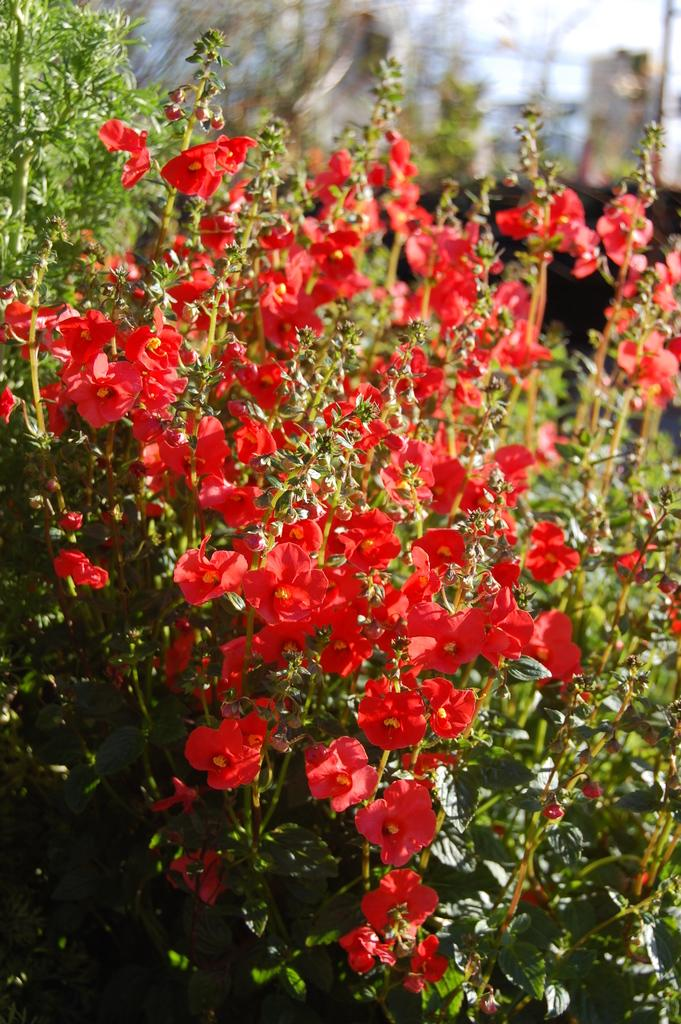What type of flowers can be seen in the front of the image? There are red color flowers in the front of the image. Where is the pole located in the image? The pole is on the top right side of the image. How would you describe the overall clarity of the image? The image is slightly blurry in the background. How many cows are present on the shelf in the image? There are no cows or shelves present in the image. What type of farm can be seen in the background of the image? There is no farm visible in the image; it features red color flowers and a pole. 